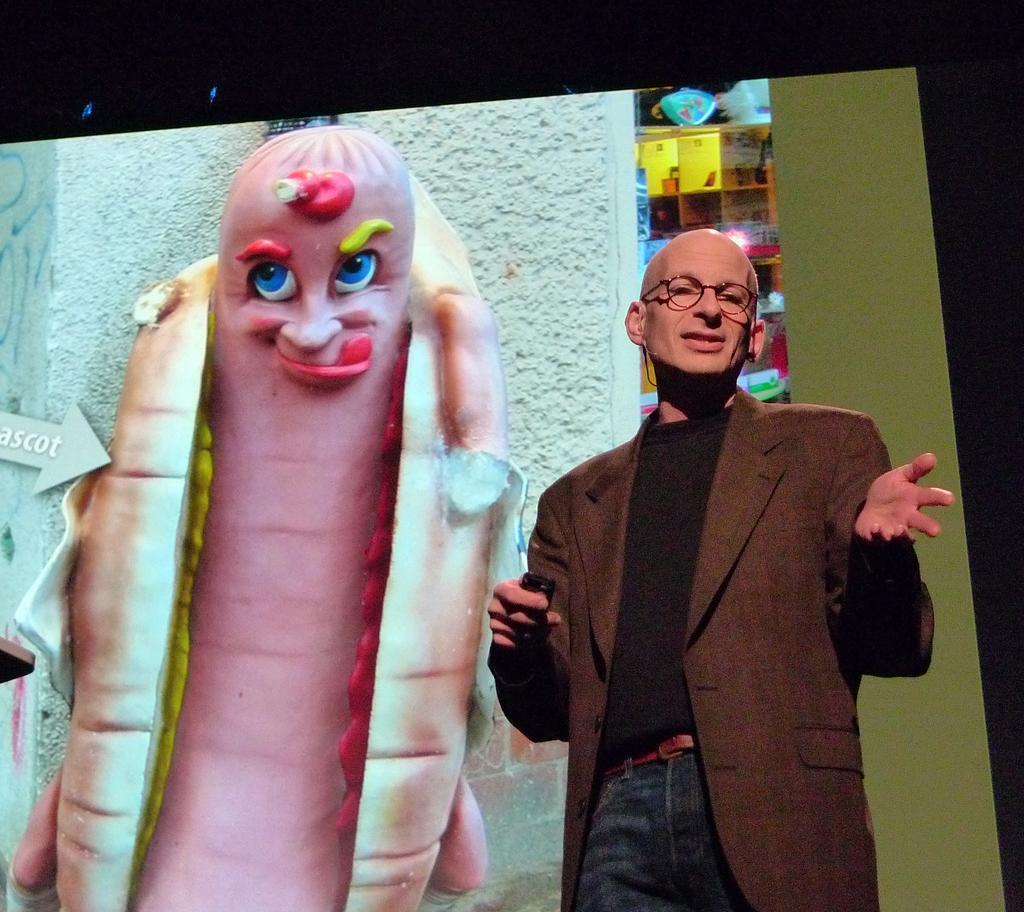Describe this image in one or two sentences. In this picture there is a man who is standing near to the poster. This poster looks like bread and hot dog who's having the nose, eyes and mouth. In the back I can see the wooden shelves. 